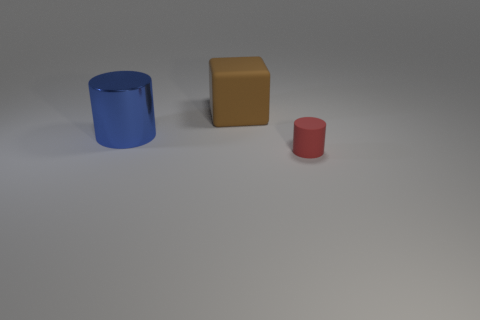Add 2 tiny blue metal cylinders. How many objects exist? 5 Subtract all blocks. How many objects are left? 2 Subtract 1 cylinders. How many cylinders are left? 1 Subtract all brown spheres. How many red cylinders are left? 1 Subtract all blue cylinders. Subtract all green rubber spheres. How many objects are left? 2 Add 3 large brown blocks. How many large brown blocks are left? 4 Add 1 small gray cylinders. How many small gray cylinders exist? 1 Subtract all blue cylinders. How many cylinders are left? 1 Subtract 0 yellow cubes. How many objects are left? 3 Subtract all cyan cubes. Subtract all yellow cylinders. How many cubes are left? 1 